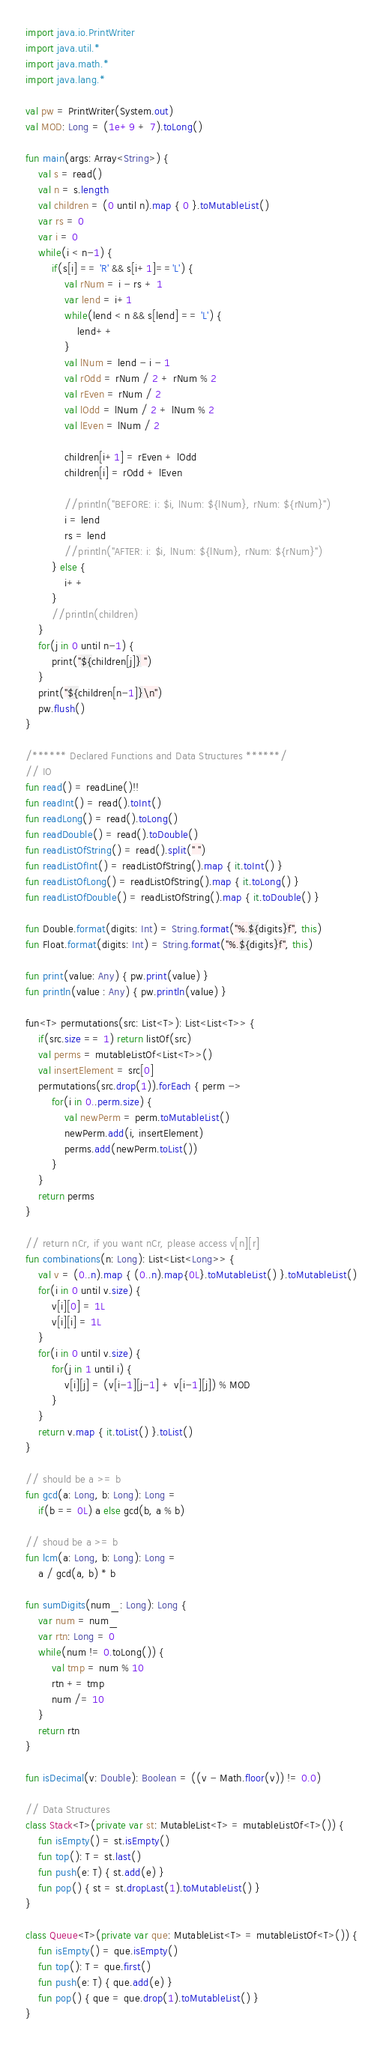Convert code to text. <code><loc_0><loc_0><loc_500><loc_500><_Kotlin_>import java.io.PrintWriter
import java.util.*
import java.math.*
import java.lang.*

val pw = PrintWriter(System.out)
val MOD: Long = (1e+9 + 7).toLong()

fun main(args: Array<String>) {
    val s = read()    
    val n = s.length
    val children = (0 until n).map { 0 }.toMutableList()
    var rs = 0
    var i = 0
    while(i < n-1) {
        if(s[i] == 'R' && s[i+1]=='L') {
            val rNum = i - rs + 1
            var lend = i+1 
            while(lend < n && s[lend] == 'L') {
                lend++
            } 
            val lNum = lend - i - 1
            val rOdd = rNum / 2 + rNum % 2 
            val rEven = rNum / 2
            val lOdd = lNum / 2 + lNum % 2
            val lEven = lNum / 2

            children[i+1] = rEven + lOdd
            children[i] = rOdd + lEven

            //println("BEFORE: i: $i, lNum: ${lNum}, rNum: ${rNum}")
            i = lend
            rs = lend
            //println("AFTER: i: $i, lNum: ${lNum}, rNum: ${rNum}")
        } else {
            i++
        }
        //println(children)
    }
    for(j in 0 until n-1) {
        print("${children[j]} ")
    }
    print("${children[n-1]}\n")
    pw.flush()
}

/****** Declared Functions and Data Structures ******/
// IO
fun read() = readLine()!!
fun readInt() = read().toInt()
fun readLong() = read().toLong()
fun readDouble() = read().toDouble()
fun readListOfString() = read().split(" ")
fun readListOfInt() = readListOfString().map { it.toInt() }
fun readListOfLong() = readListOfString().map { it.toLong() }
fun readListOfDouble() = readListOfString().map { it.toDouble() }

fun Double.format(digits: Int) = String.format("%.${digits}f", this)
fun Float.format(digits: Int) = String.format("%.${digits}f", this)

fun print(value: Any) { pw.print(value) }
fun println(value : Any) { pw.println(value) }

fun<T> permutations(src: List<T>): List<List<T>> {
    if(src.size == 1) return listOf(src)
    val perms = mutableListOf<List<T>>()
    val insertElement = src[0]
    permutations(src.drop(1)).forEach { perm ->
        for(i in 0..perm.size) {
            val newPerm = perm.toMutableList()
            newPerm.add(i, insertElement)
            perms.add(newPerm.toList())
        }
    }
    return perms
}

// return nCr, if you want nCr, please access v[n][r]
fun combinations(n: Long): List<List<Long>> {
    val v = (0..n).map { (0..n).map{0L}.toMutableList() }.toMutableList()
    for(i in 0 until v.size) {
        v[i][0] = 1L
        v[i][i] = 1L
    }
    for(i in 0 until v.size) {
        for(j in 1 until i) {
            v[i][j] = (v[i-1][j-1] + v[i-1][j]) % MOD
        }
    }
    return v.map { it.toList() }.toList()
}

// should be a >= b
fun gcd(a: Long, b: Long): Long = 
    if(b == 0L) a else gcd(b, a % b)

// shoud be a >= b
fun lcm(a: Long, b: Long): Long = 
    a / gcd(a, b) * b

fun sumDigits(num_: Long): Long {
    var num = num_
    var rtn: Long = 0
    while(num != 0.toLong()) {
        val tmp = num % 10
        rtn += tmp
        num /= 10
    }
    return rtn
}

fun isDecimal(v: Double): Boolean = ((v - Math.floor(v)) != 0.0)

// Data Structures
class Stack<T>(private var st: MutableList<T> = mutableListOf<T>()) {
    fun isEmpty() = st.isEmpty()
    fun top(): T = st.last()
    fun push(e: T) { st.add(e) }
    fun pop() { st = st.dropLast(1).toMutableList() }
}

class Queue<T>(private var que: MutableList<T> = mutableListOf<T>()) {
    fun isEmpty() = que.isEmpty()
    fun top(): T = que.first()
    fun push(e: T) { que.add(e) }
    fun pop() { que = que.drop(1).toMutableList() }
}
</code> 